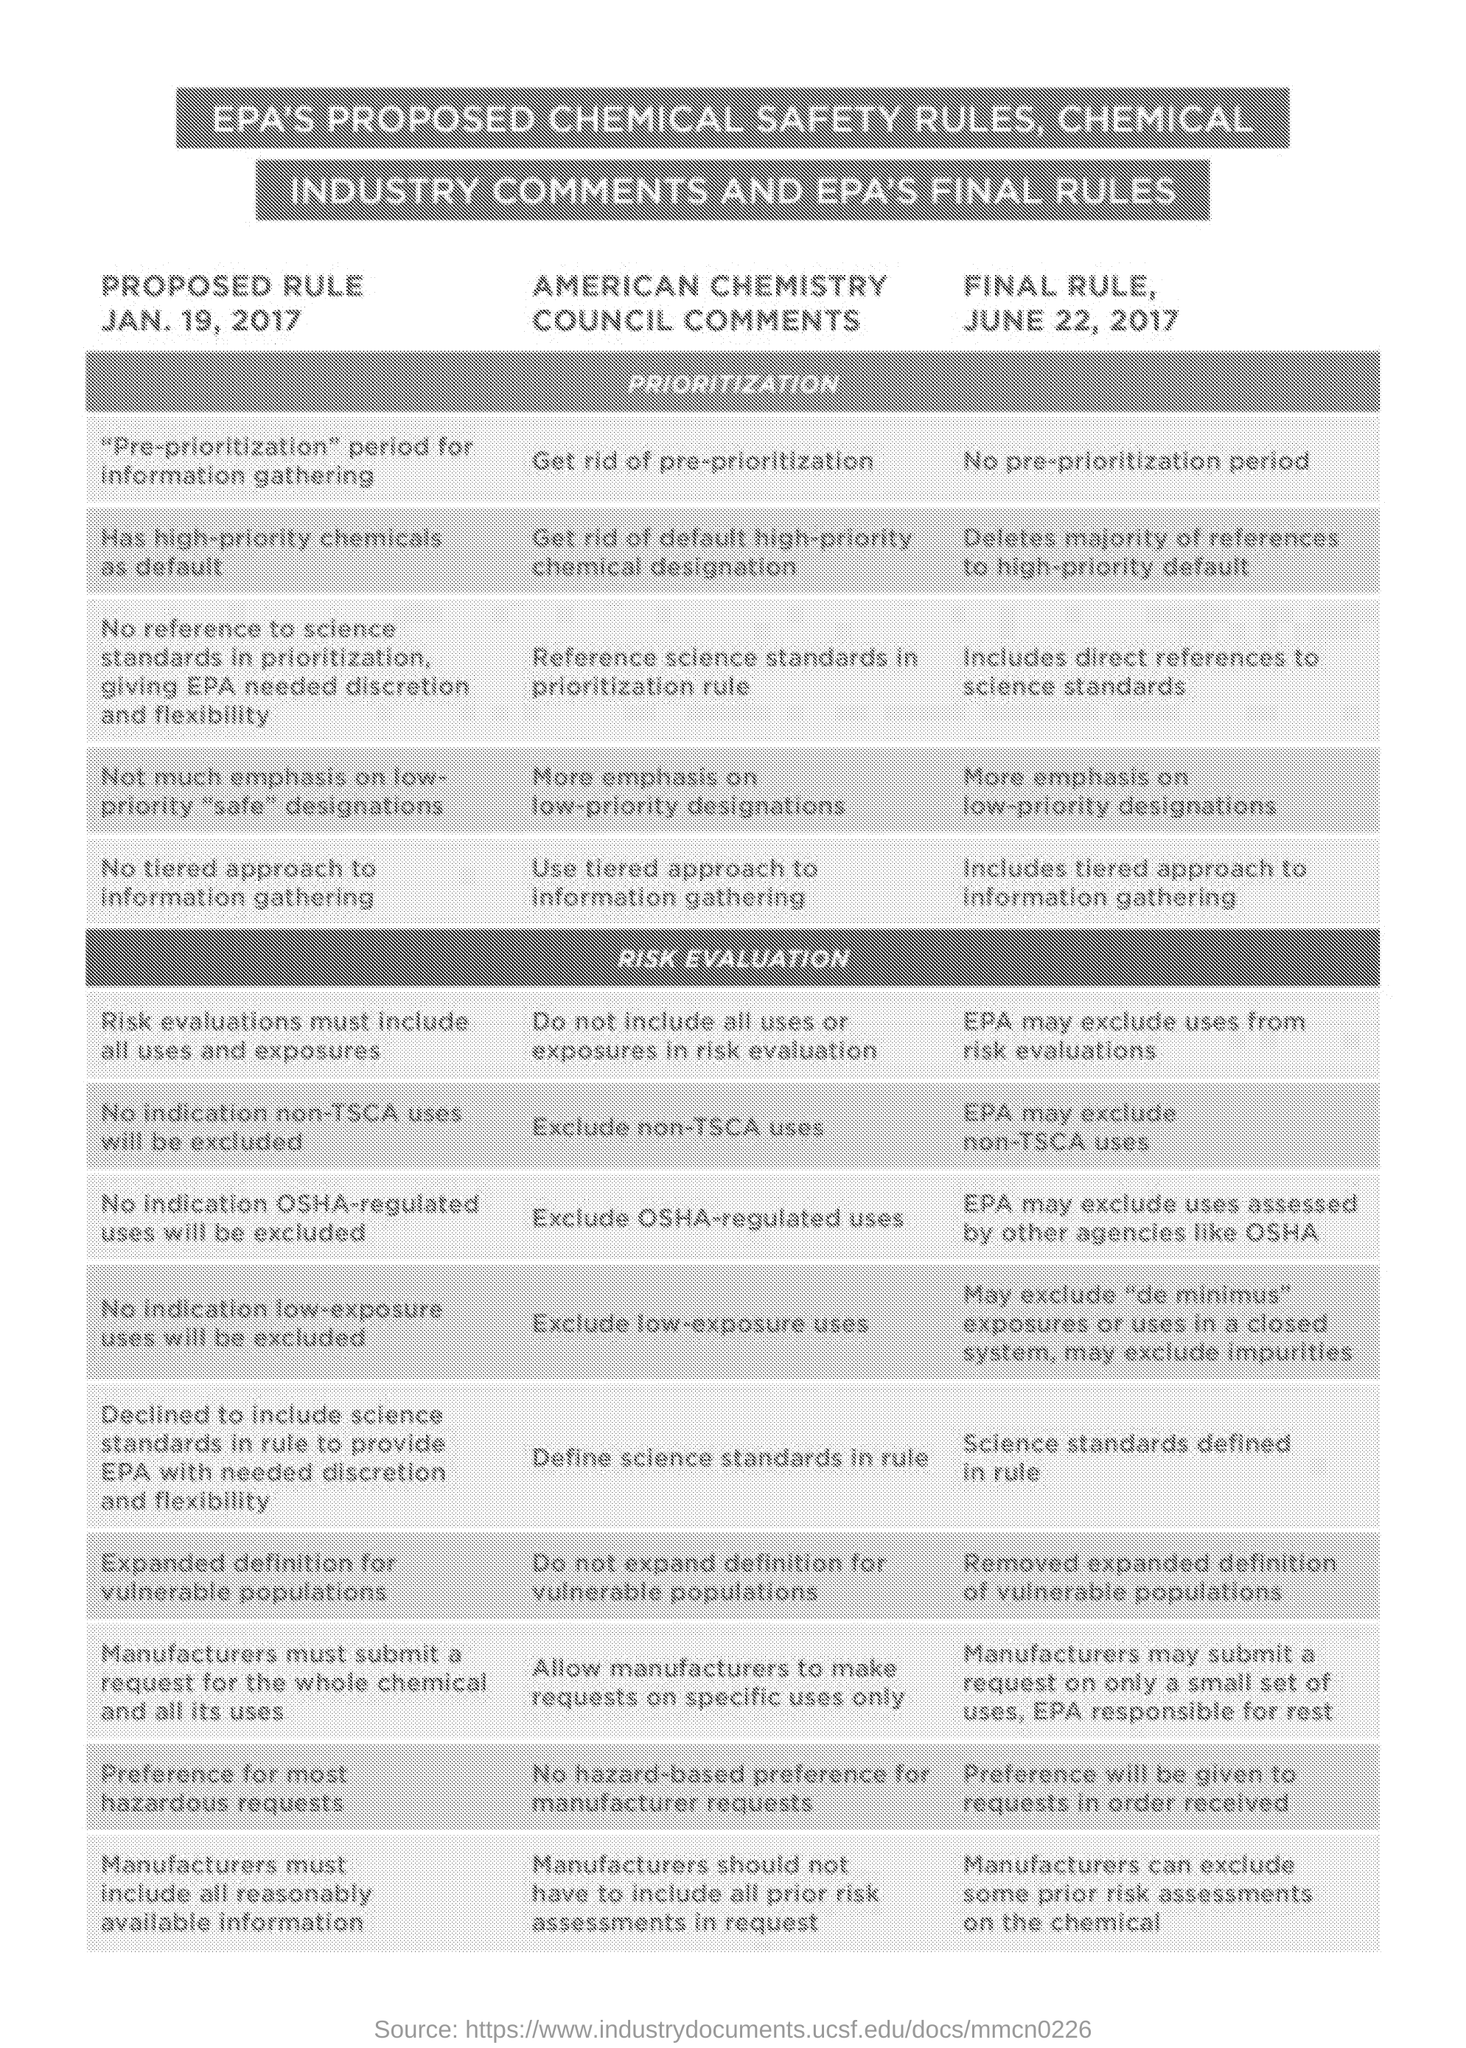Indicate a few pertinent items in this graphic. As of January 19, 2017, the rule was proposed. 